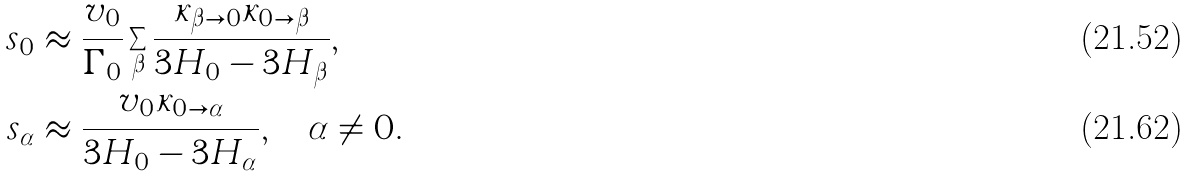<formula> <loc_0><loc_0><loc_500><loc_500>s _ { 0 } & \approx \frac { v _ { 0 } } { \Gamma _ { 0 } } \sum _ { \beta } \frac { \kappa _ { \beta \rightarrow 0 } \kappa _ { 0 \rightarrow \beta } } { 3 H _ { 0 } - 3 H _ { \beta } } , \\ s _ { \alpha } & \approx \frac { v _ { 0 } \kappa _ { 0 \rightarrow \alpha } } { 3 H _ { 0 } - 3 H _ { \alpha } } , \quad \alpha \neq 0 .</formula> 